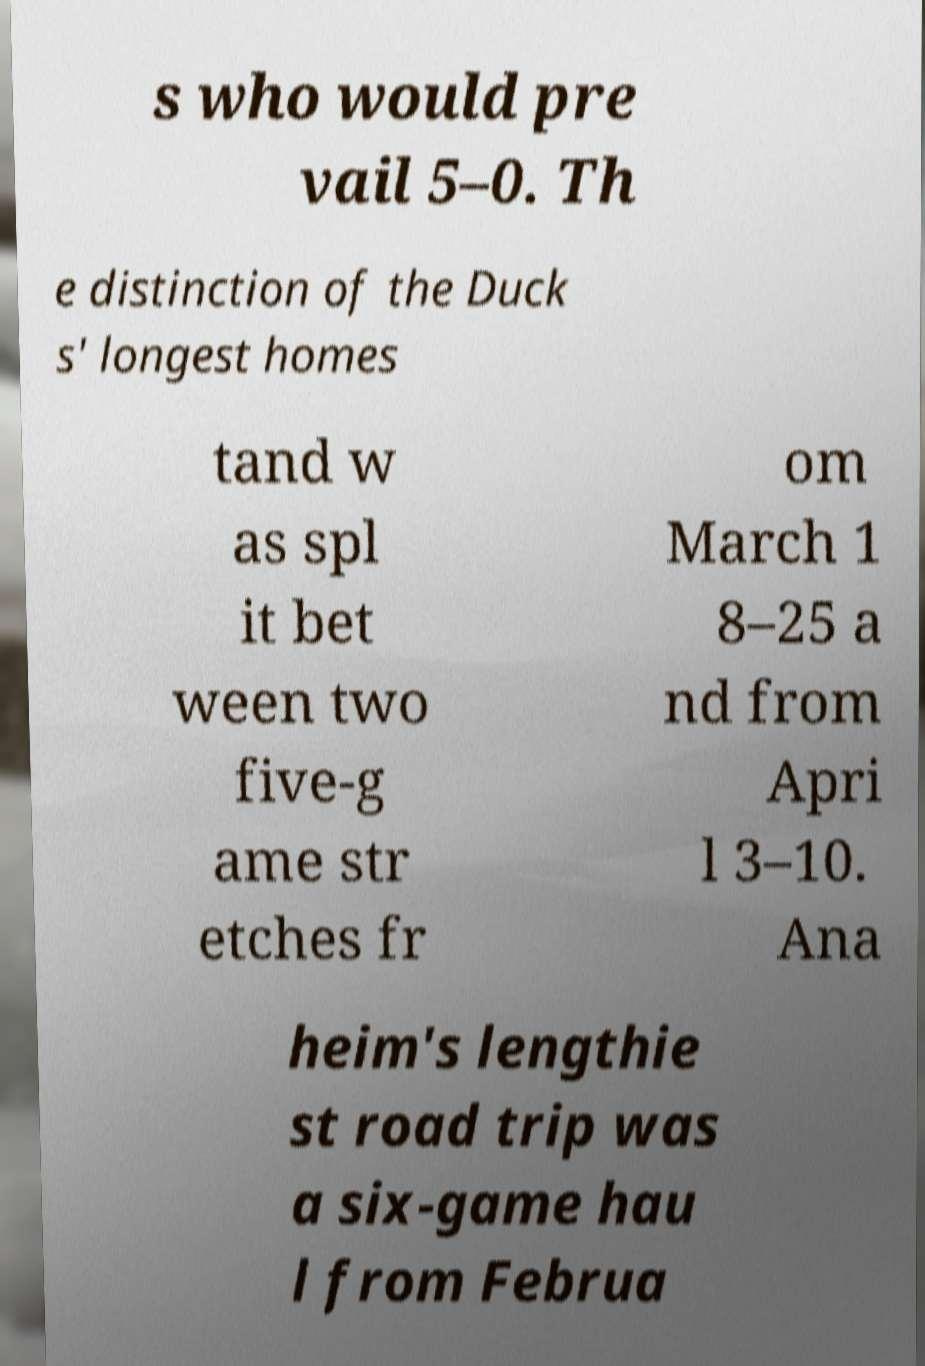There's text embedded in this image that I need extracted. Can you transcribe it verbatim? s who would pre vail 5–0. Th e distinction of the Duck s' longest homes tand w as spl it bet ween two five-g ame str etches fr om March 1 8–25 a nd from Apri l 3–10. Ana heim's lengthie st road trip was a six-game hau l from Februa 